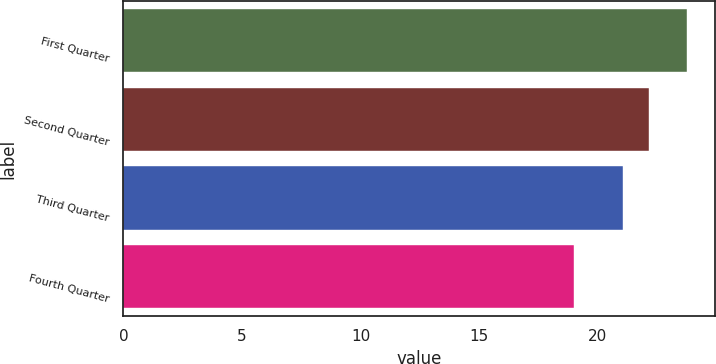Convert chart. <chart><loc_0><loc_0><loc_500><loc_500><bar_chart><fcel>First Quarter<fcel>Second Quarter<fcel>Third Quarter<fcel>Fourth Quarter<nl><fcel>23.76<fcel>22.14<fcel>21.05<fcel>18.99<nl></chart> 